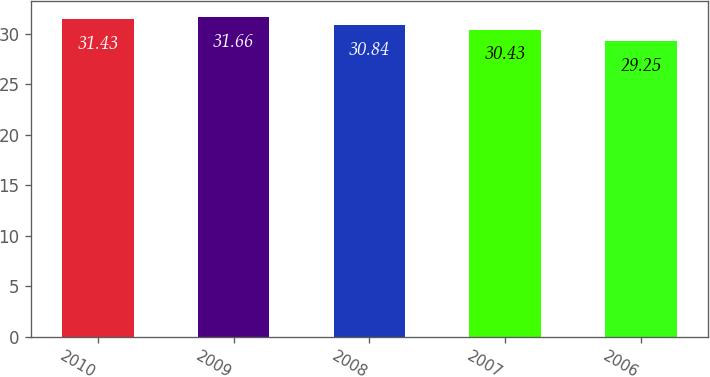<chart> <loc_0><loc_0><loc_500><loc_500><bar_chart><fcel>2010<fcel>2009<fcel>2008<fcel>2007<fcel>2006<nl><fcel>31.43<fcel>31.66<fcel>30.84<fcel>30.43<fcel>29.25<nl></chart> 